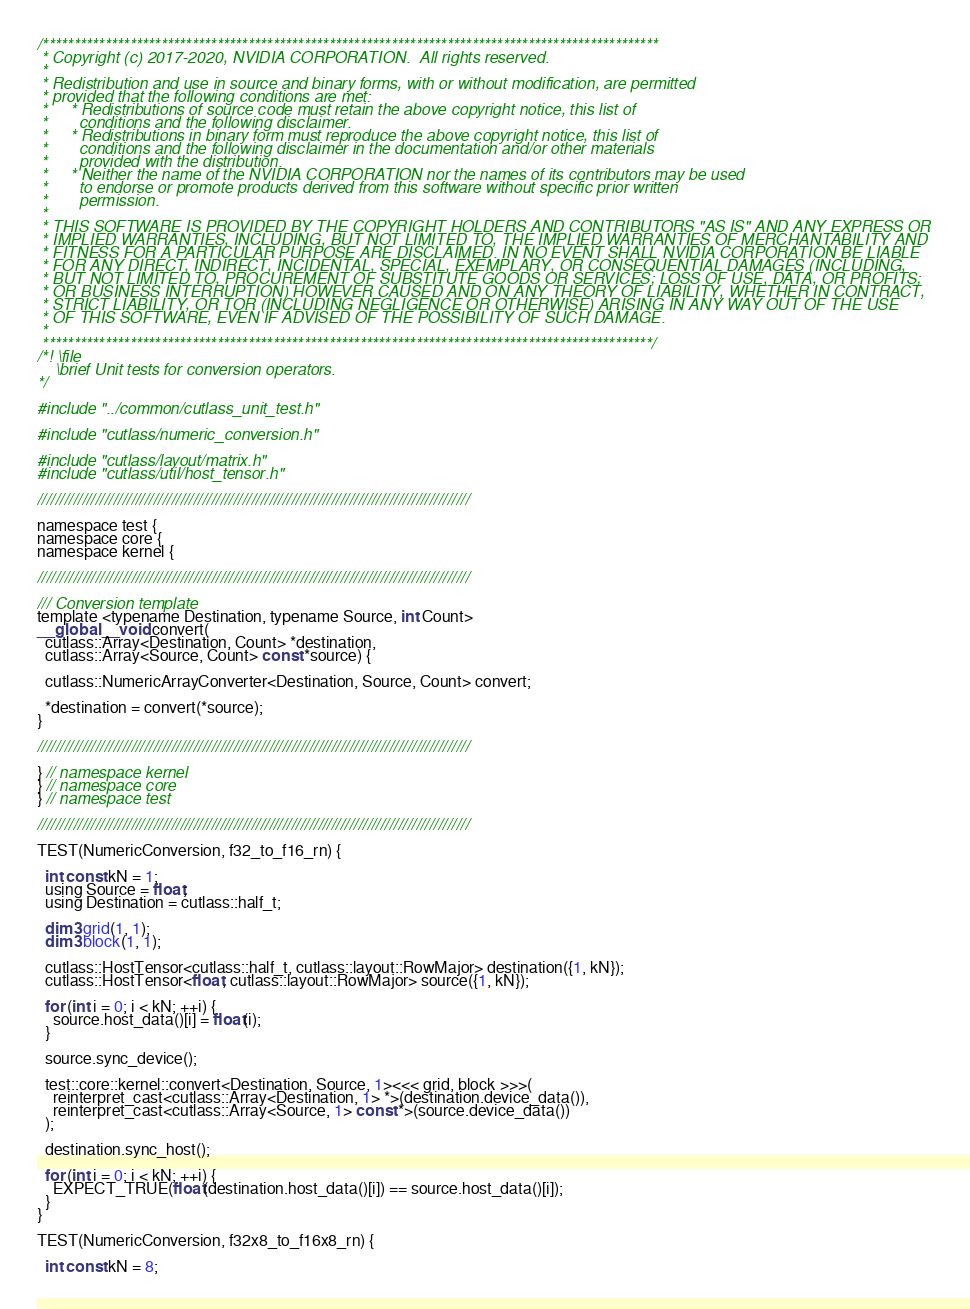Convert code to text. <code><loc_0><loc_0><loc_500><loc_500><_Cuda_>/***************************************************************************************************
 * Copyright (c) 2017-2020, NVIDIA CORPORATION.  All rights reserved.
 *
 * Redistribution and use in source and binary forms, with or without modification, are permitted
 * provided that the following conditions are met:
 *     * Redistributions of source code must retain the above copyright notice, this list of
 *       conditions and the following disclaimer.
 *     * Redistributions in binary form must reproduce the above copyright notice, this list of
 *       conditions and the following disclaimer in the documentation and/or other materials
 *       provided with the distribution.
 *     * Neither the name of the NVIDIA CORPORATION nor the names of its contributors may be used
 *       to endorse or promote products derived from this software without specific prior written
 *       permission.
 *
 * THIS SOFTWARE IS PROVIDED BY THE COPYRIGHT HOLDERS AND CONTRIBUTORS "AS IS" AND ANY EXPRESS OR
 * IMPLIED WARRANTIES, INCLUDING, BUT NOT LIMITED TO, THE IMPLIED WARRANTIES OF MERCHANTABILITY AND
 * FITNESS FOR A PARTICULAR PURPOSE ARE DISCLAIMED. IN NO EVENT SHALL NVIDIA CORPORATION BE LIABLE
 * FOR ANY DIRECT, INDIRECT, INCIDENTAL, SPECIAL, EXEMPLARY, OR CONSEQUENTIAL DAMAGES (INCLUDING,
 * BUT NOT LIMITED TO, PROCUREMENT OF SUBSTITUTE GOODS OR SERVICES; LOSS OF USE, DATA, OR PROFITS;
 * OR BUSINESS INTERRUPTION) HOWEVER CAUSED AND ON ANY THEORY OF LIABILITY, WHETHER IN CONTRACT,
 * STRICT LIABILITY, OR TOR (INCLUDING NEGLIGENCE OR OTHERWISE) ARISING IN ANY WAY OUT OF THE USE
 * OF THIS SOFTWARE, EVEN IF ADVISED OF THE POSSIBILITY OF SUCH DAMAGE.
 *
 **************************************************************************************************/
/*! \file
    \brief Unit tests for conversion operators.
*/

#include "../common/cutlass_unit_test.h"

#include "cutlass/numeric_conversion.h"

#include "cutlass/layout/matrix.h"
#include "cutlass/util/host_tensor.h"

/////////////////////////////////////////////////////////////////////////////////////////////////

namespace test {
namespace core {
namespace kernel {

/////////////////////////////////////////////////////////////////////////////////////////////////

/// Conversion template
template <typename Destination, typename Source, int Count>
__global__ void convert(
  cutlass::Array<Destination, Count> *destination, 
  cutlass::Array<Source, Count> const *source) {

  cutlass::NumericArrayConverter<Destination, Source, Count> convert;

  *destination = convert(*source);
}

/////////////////////////////////////////////////////////////////////////////////////////////////

} // namespace kernel
} // namespace core
} // namespace test

/////////////////////////////////////////////////////////////////////////////////////////////////

TEST(NumericConversion, f32_to_f16_rn) {

  int const kN = 1;
  using Source = float;
  using Destination = cutlass::half_t;

  dim3 grid(1, 1);
  dim3 block(1, 1);

  cutlass::HostTensor<cutlass::half_t, cutlass::layout::RowMajor> destination({1, kN});
  cutlass::HostTensor<float, cutlass::layout::RowMajor> source({1, kN});

  for (int i = 0; i < kN; ++i) {
    source.host_data()[i] = float(i);
  }

  source.sync_device();

  test::core::kernel::convert<Destination, Source, 1><<< grid, block >>>(
    reinterpret_cast<cutlass::Array<Destination, 1> *>(destination.device_data()),
    reinterpret_cast<cutlass::Array<Source, 1> const *>(source.device_data())
  );

  destination.sync_host();

  for (int i = 0; i < kN; ++i) {
    EXPECT_TRUE(float(destination.host_data()[i]) == source.host_data()[i]);
  }
}

TEST(NumericConversion, f32x8_to_f16x8_rn) {

  int const kN = 8;</code> 